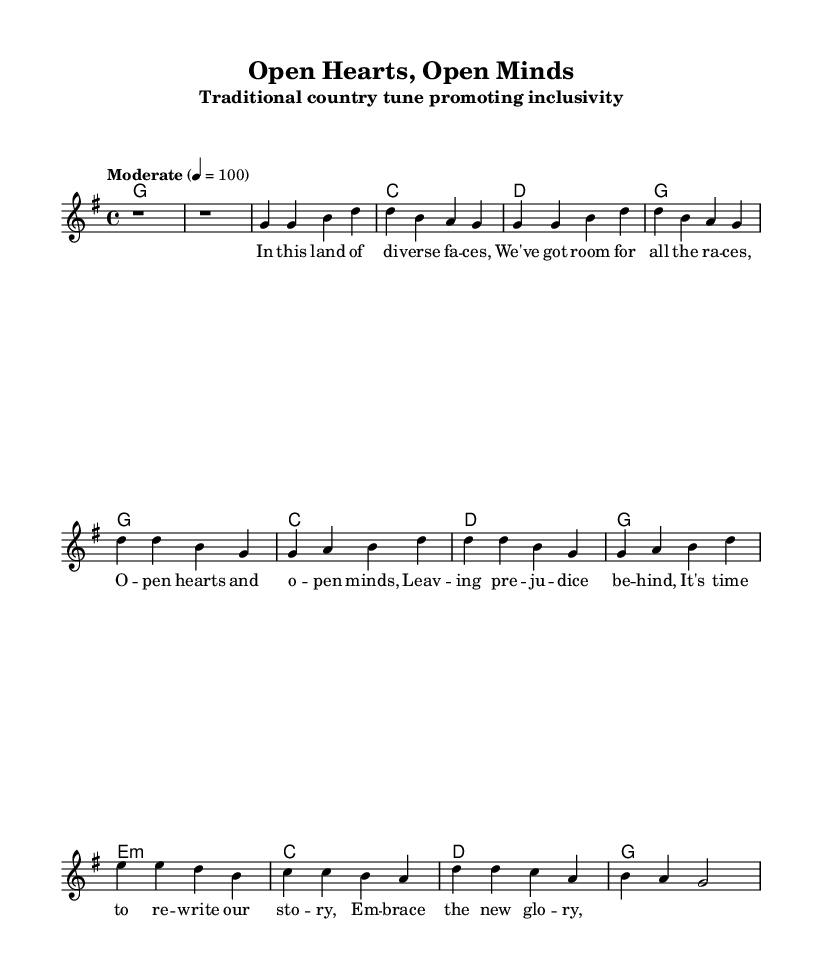What is the key signature of this music? The key signature is G major, which has one sharp (F#). This is determined from the beginning of the score where the key signature is displayed.
Answer: G major What is the time signature of the piece? The time signature is four-four, as indicated at the beginning of the score. This tells us there are four beats in each measure.
Answer: Four-four What is the tempo marking of the music? The tempo marking is "Moderate," with a metronome marking of 100 beats per minute. This is indicated at the top of the score.
Answer: Moderate, 100 How many measures are there in the chorus? The chorus consists of two measures, as we see it is repeated and visually identifiable in the sheet music. Each part labeled "Chorus" has its own measures outlined.
Answer: Two What theme do the lyrics in the first verse promote? The lyrics promote inclusivity and acceptance of diversity, emphasizing the need to leave prejudice behind. This is derived from the text in the verse as it refers to "open hearts" and "diverse faces."
Answer: Inclusivity Are there any harmonies indicated for the bridge section? Yes, the bridge section indicates a minor chord with "e1:m" followed by standard chords. This is clear from the chord changes listed directly above the melody in the score.
Answer: Yes, e minor How does the structure of this country tune reflect traditional styles? The structure of the tune follows a conventional verse-chorus format, common in traditional country music, promoting storytelling through its lyrics and repetitive melody patterns, which are characteristic features.
Answer: Verse-chorus format 